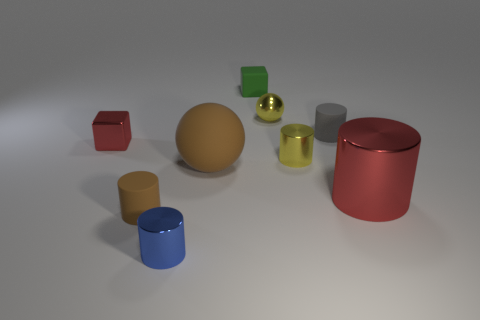Subtract all red cylinders. How many cylinders are left? 4 Subtract all yellow shiny cylinders. How many cylinders are left? 4 Subtract all green cylinders. Subtract all red spheres. How many cylinders are left? 5 Add 1 tiny yellow shiny balls. How many objects exist? 10 Subtract all spheres. How many objects are left? 7 Subtract 0 gray balls. How many objects are left? 9 Subtract all brown spheres. Subtract all small green rubber objects. How many objects are left? 7 Add 4 big brown spheres. How many big brown spheres are left? 5 Add 4 tiny gray shiny objects. How many tiny gray shiny objects exist? 4 